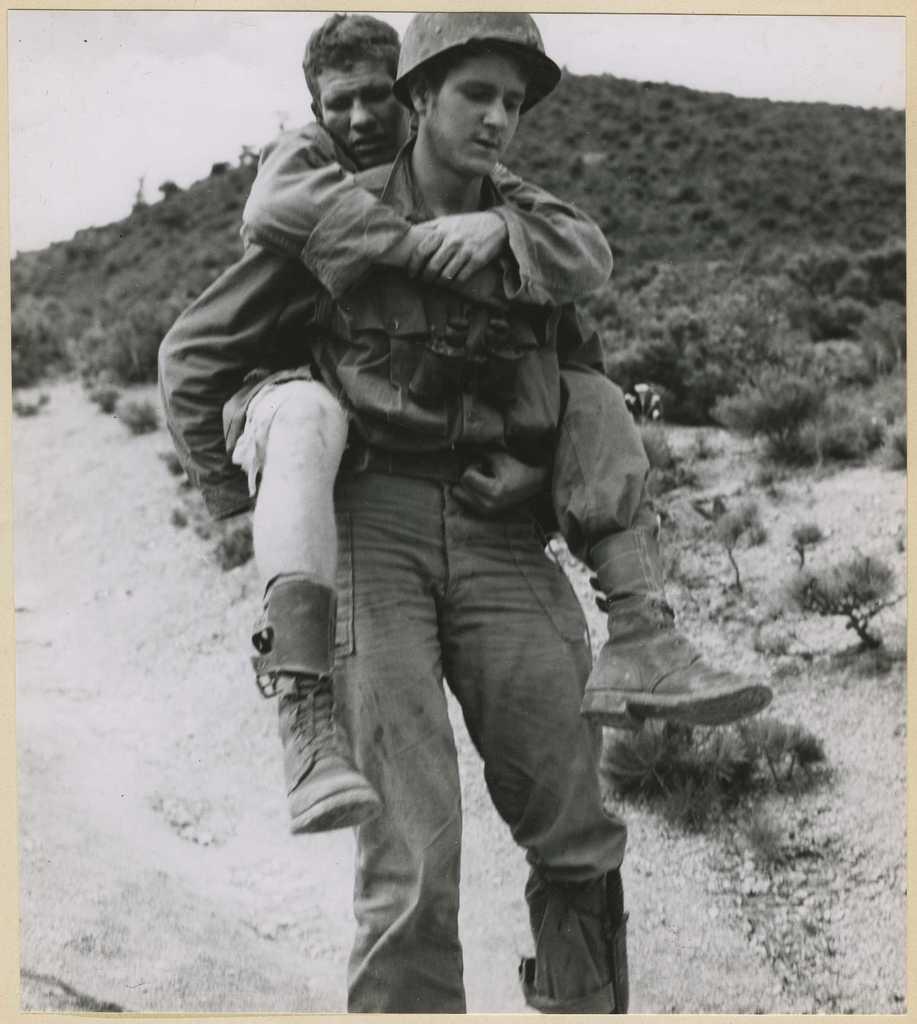Describe this image in one or two sentences. This is a black and white image I can see a person carrying another person and walking on the road, beside him there are so many plants and mountain. 